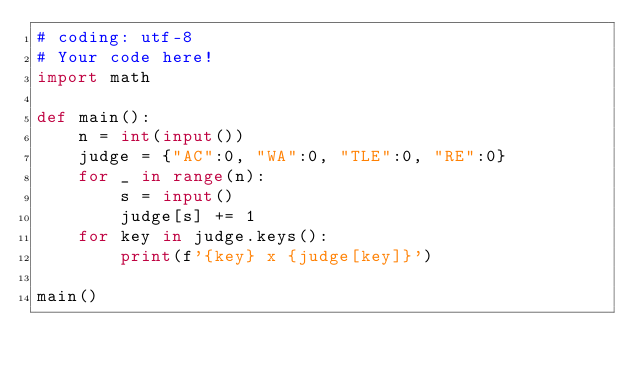Convert code to text. <code><loc_0><loc_0><loc_500><loc_500><_Python_># coding: utf-8
# Your code here!
import math

def main():
    n = int(input())
    judge = {"AC":0, "WA":0, "TLE":0, "RE":0}
    for _ in range(n):
        s = input()
        judge[s] += 1
    for key in judge.keys():
        print(f'{key} x {judge[key]}')
    
main()</code> 